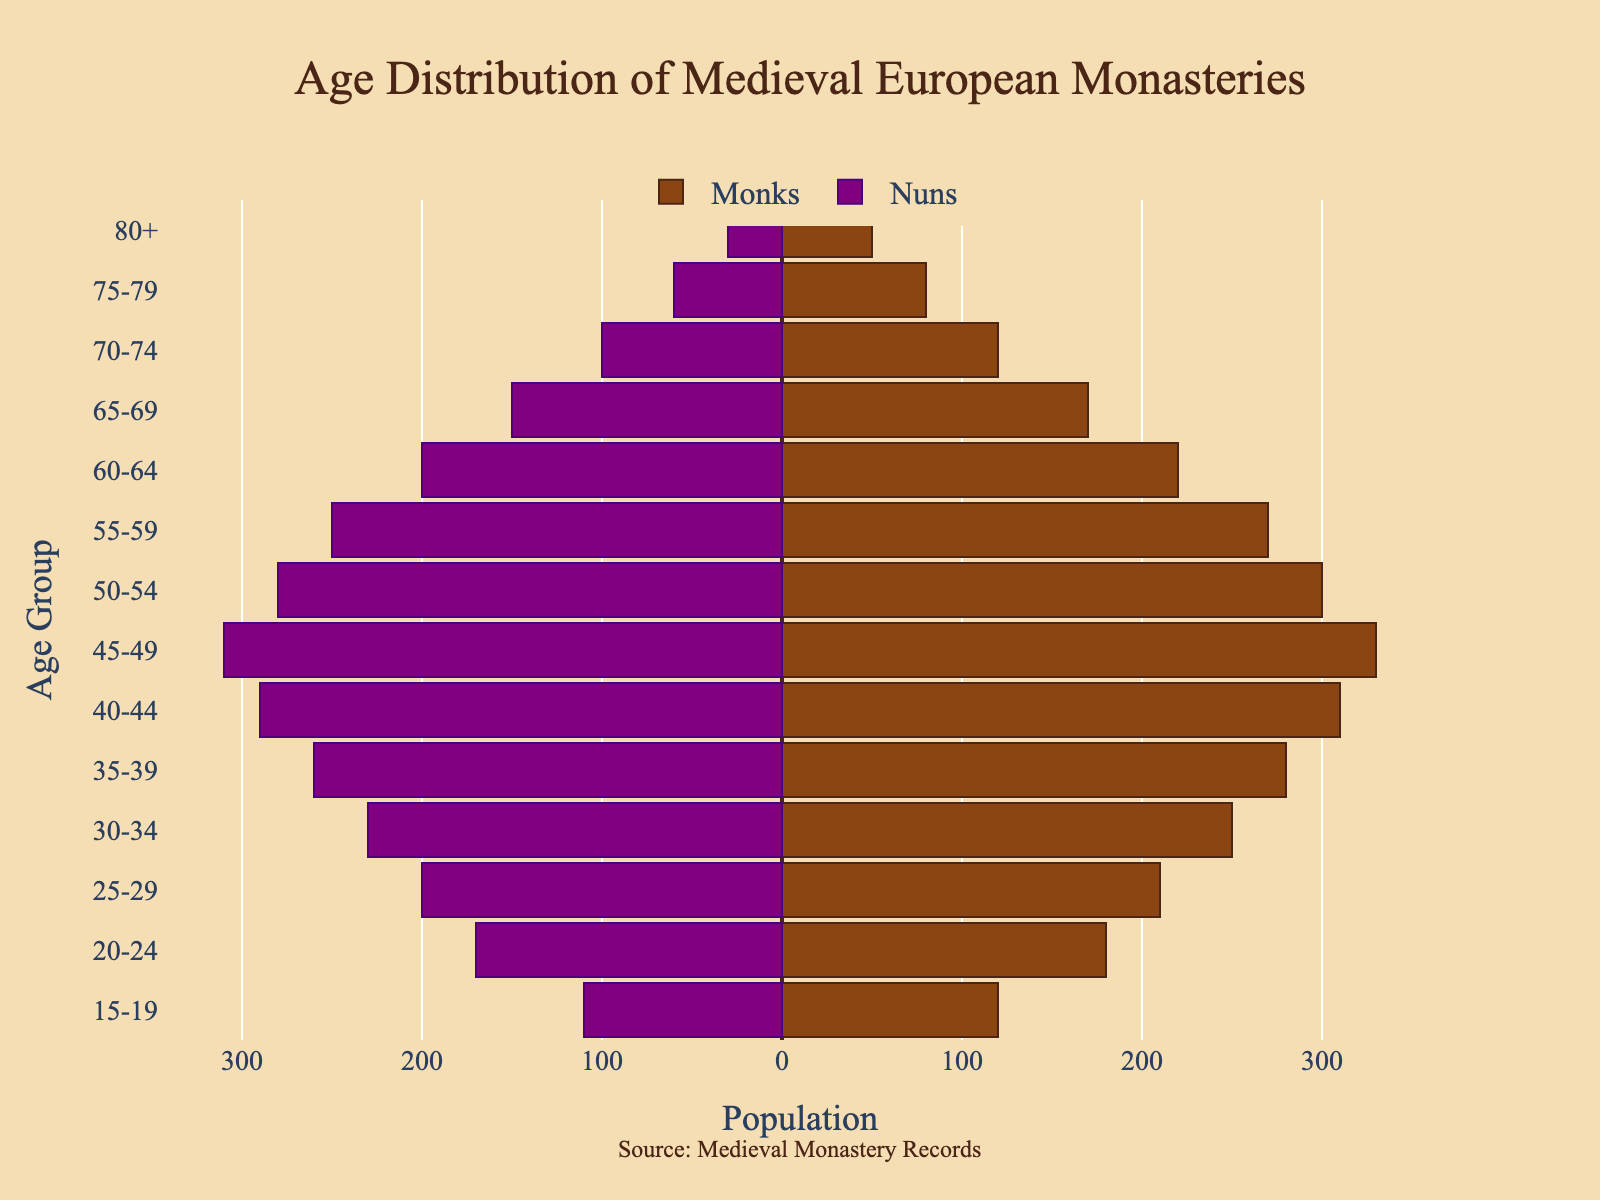What is the title of the figure? The title of the figure is located at the top of the plot. It is the text displayed prominently in a larger font than the rest.
Answer: Age Distribution of Medieval European Monasteries How many age groups are displayed in the figure? By counting the discrete bands on the y-axis from top to bottom, we can calculate the number of age groups.
Answer: 14 What color represents the monks in the figure? The color assigned to monks can be identified by looking at the legend or the bars on the plot that correspond to monks. It is a brownish shade.
Answer: Brown In which age group is the number of monks the highest? By comparing the lengths of the bars representing monks across all age groups, the age group with the longest bar for monks indicates the highest number.
Answer: 45-49 How many nuns are in the 30-34 age group? The plot shows negative values for nuns. Locate the bar corresponding to the 30-34 age group on the y-axis, then observe its length on the x-axis, which shows a value of -230. The absolute value provides the count.
Answer: 230 In which age group is the gender difference (Monks - Nuns) the greatest? To determine this, calculate the absolute difference for each age group. The age group with the largest absolute value signifies the greatest difference. For instance, for the 45-49 age group: the difference is 330 - 310 = 20.
Answer: 15-19 What is the total number of monks displayed in the figure across all age groups? Sum the counts of monks for each age group: 120 + 180 + 210 + 250 + 280 + 310 + 330 + 300 + 270 + 220 + 170 + 120 + 80 + 50 = 2890.
Answer: 2890 Which age group has the closest number of monks and nuns? Check each age group for the smallest difference between monks and nuns. Calculate the absolute differences, e.g., 280 - 260 for 35-39 age group is 20, and find the smallest one.
Answer: 45-49 At what age group do the numbers of monks and nuns both begin to decline? Observe at which age group onward both monk and nun populations simultaneously start showing shorter bars compared to the previous age group.
Answer: 50-54 What is the population difference between monks and nuns in the 80+ age group? For the 80+ age group, subtract the number of nuns from the number of monks: 50 - 30 = 20.
Answer: 20 